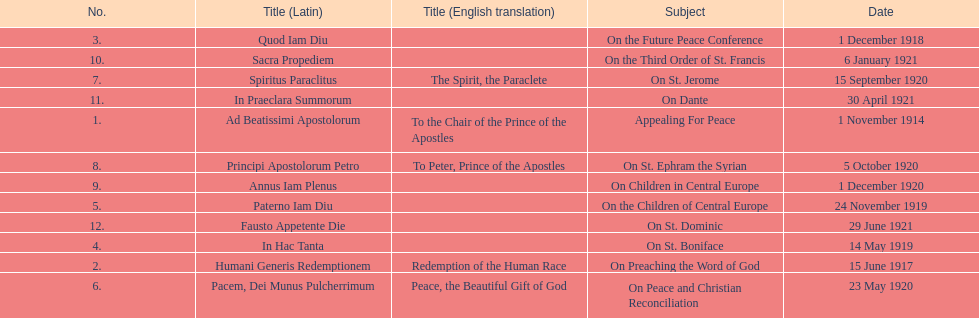Give me the full table as a dictionary. {'header': ['No.', 'Title (Latin)', 'Title (English translation)', 'Subject', 'Date'], 'rows': [['3.', 'Quod Iam Diu', '', 'On the Future Peace Conference', '1 December 1918'], ['10.', 'Sacra Propediem', '', 'On the Third Order of St. Francis', '6 January 1921'], ['7.', 'Spiritus Paraclitus', 'The Spirit, the Paraclete', 'On St. Jerome', '15 September 1920'], ['11.', 'In Praeclara Summorum', '', 'On Dante', '30 April 1921'], ['1.', 'Ad Beatissimi Apostolorum', 'To the Chair of the Prince of the Apostles', 'Appealing For Peace', '1 November 1914'], ['8.', 'Principi Apostolorum Petro', 'To Peter, Prince of the Apostles', 'On St. Ephram the Syrian', '5 October 1920'], ['9.', 'Annus Iam Plenus', '', 'On Children in Central Europe', '1 December 1920'], ['5.', 'Paterno Iam Diu', '', 'On the Children of Central Europe', '24 November 1919'], ['12.', 'Fausto Appetente Die', '', 'On St. Dominic', '29 June 1921'], ['4.', 'In Hac Tanta', '', 'On St. Boniface', '14 May 1919'], ['2.', 'Humani Generis Redemptionem', 'Redemption of the Human Race', 'On Preaching the Word of God', '15 June 1917'], ['6.', 'Pacem, Dei Munus Pulcherrimum', 'Peace, the Beautiful Gift of God', 'On Peace and Christian Reconciliation', '23 May 1920']]} What is the subject listed after appealing for peace? On Preaching the Word of God. 